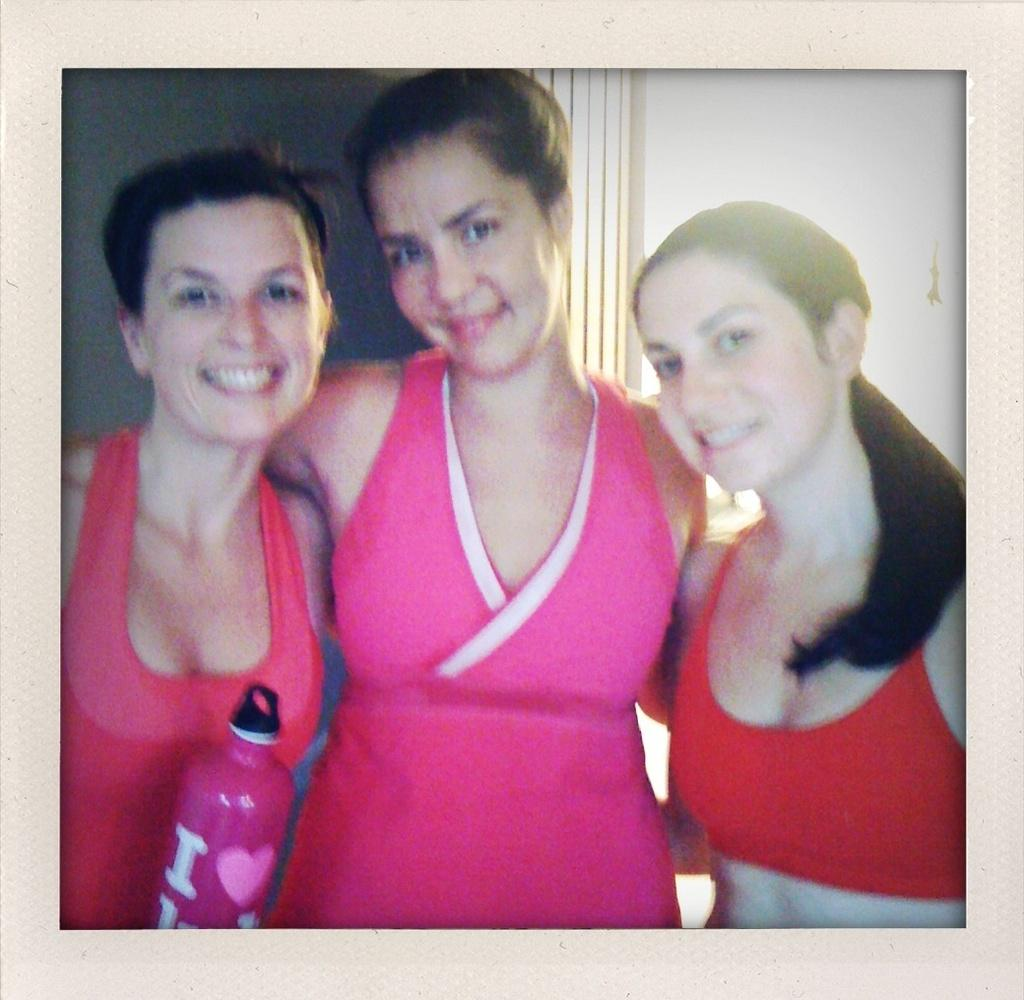What object can be seen in the image that typically holds a picture? There is a photo frame in the image. How many ladies are present in the image? There are three ladies in the image. What is one of the ladies holding? One lady is holding a bottle. What can be seen behind the ladies in the image? There is a wall in the background of the image. What type of crow can be seen resting on the photo frame in the image? There is no crow present in the image; it only features three ladies and a photo frame. What shape is the photo frame in the image? The shape of the photo frame cannot be determined from the image alone. 